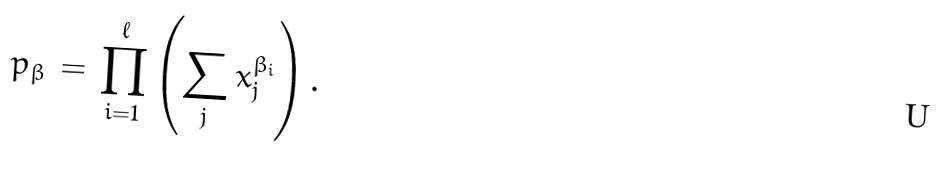Convert formula to latex. <formula><loc_0><loc_0><loc_500><loc_500>p _ { \beta } \, = \, \prod _ { i = 1 } ^ { \ell } \left ( \sum _ { j } x _ { j } ^ { \beta _ { i } } \right ) .</formula> 